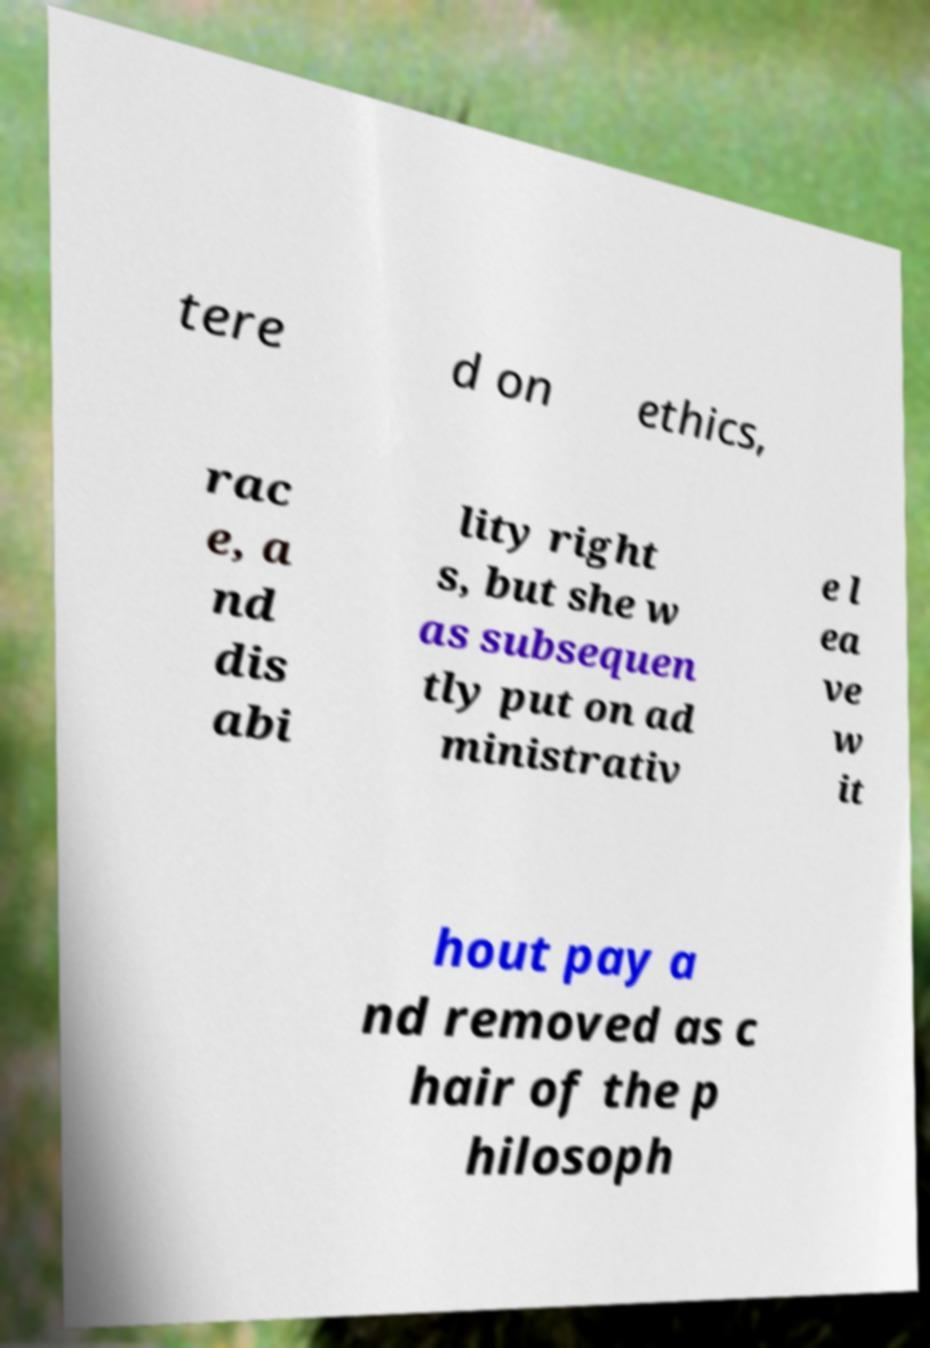Could you assist in decoding the text presented in this image and type it out clearly? tere d on ethics, rac e, a nd dis abi lity right s, but she w as subsequen tly put on ad ministrativ e l ea ve w it hout pay a nd removed as c hair of the p hilosoph 